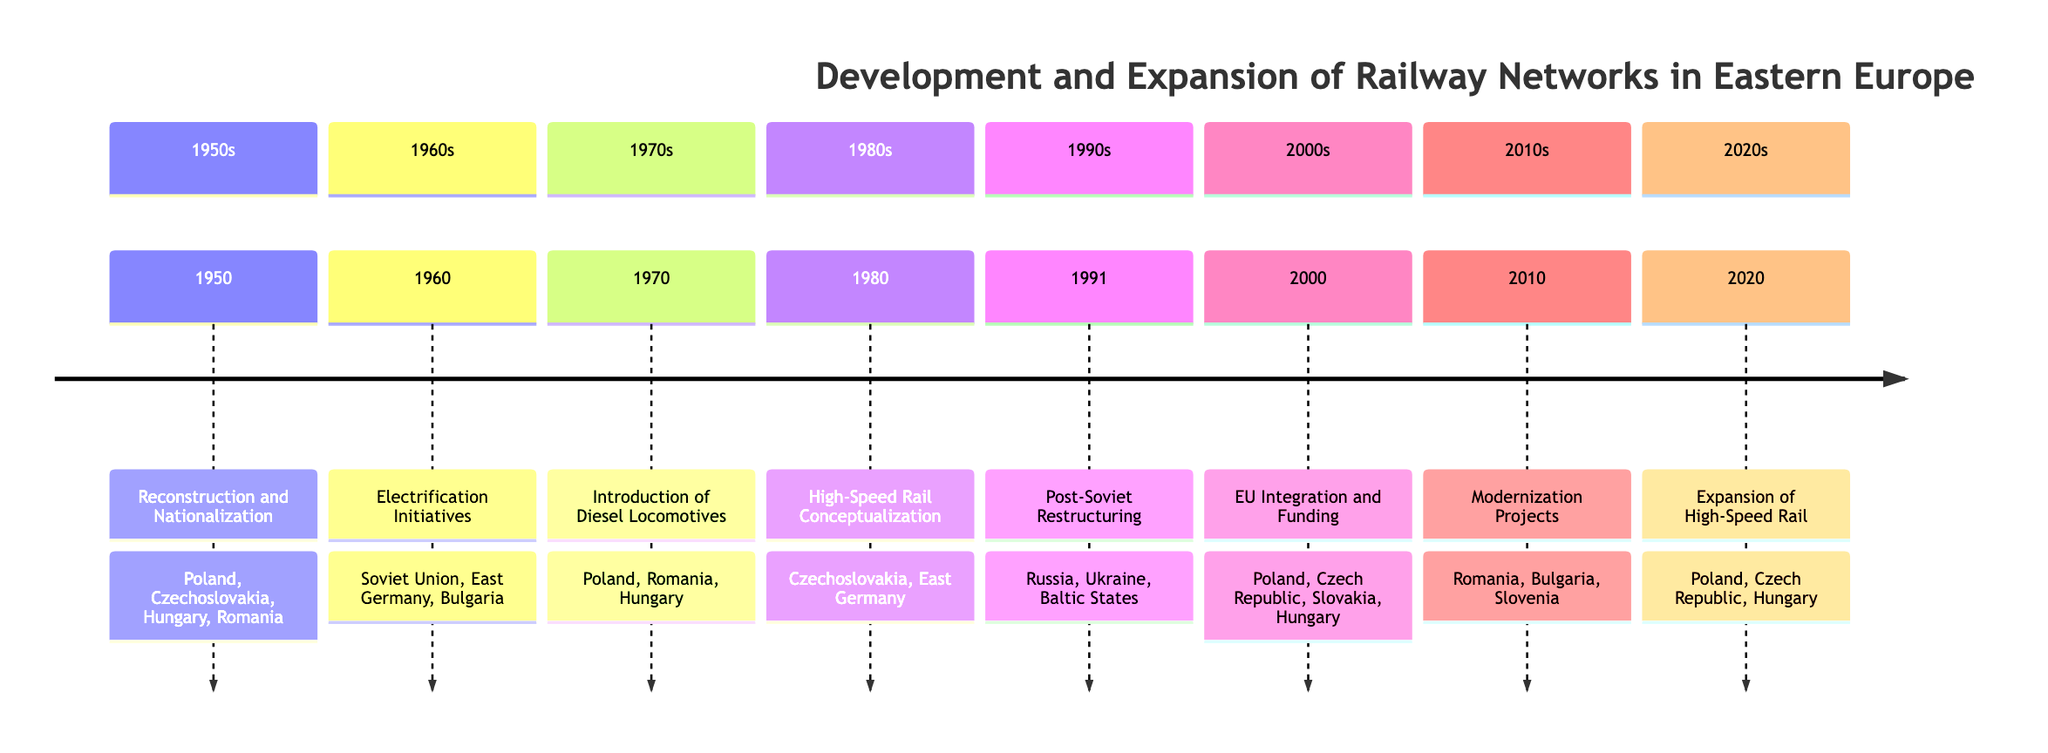What event occurred in 1970? The timeline indicates the event "Introduction of Diesel Locomotives" took place in 1970, marking a significant technological advancement in rail transport.
Answer: Introduction of Diesel Locomotives Which countries were involved in the Electrification Initiatives? The diagram shows that the event in 1960 involved the Soviet Union, East Germany, and Bulgaria in significant investments in electrification.
Answer: Soviet Union, East Germany, Bulgaria How many events are listed for the 1980s? There is only one event shown in the timeline for the 1980s, which is "High-Speed Rail Conceptualization" in the year 1980.
Answer: 1 What significant restructuring happened in 1991? The diagram specifies that the event in 1991 was "Post-Soviet Restructuring," referring to changes in rail transport sectors after the collapse of the Soviet Union.
Answer: Post-Soviet Restructuring Which technological advancement was highlighted in 2010? According to the timeline, the event described in 2010 is "Modernization Projects," which included upgrades to railway infrastructure and advanced signaling systems.
Answer: Modernization Projects Which years saw the introduction or expansion of high-speed rail concepts? Reviewing the timeline, high-speed rail concepts were introduced in 1980 and further expanded in 2020, indicating two separate years related to high-speed rail.
Answer: 1980, 2020 What event marked EU Integration and Funding in 2000? The timeline highlights "EU Integration and Funding" as the main event in 2000, reflecting the changes due to Eastern European countries' joining the EU.
Answer: EU Integration and Funding How did the 1991 event affect the countries listed? The event "Post-Soviet Restructuring" in 1991 involved restructuring and privatization in the countries of Russia, Ukraine, and the Baltic States, impacting their rail systems significantly.
Answer: Russia, Ukraine, Baltic States 